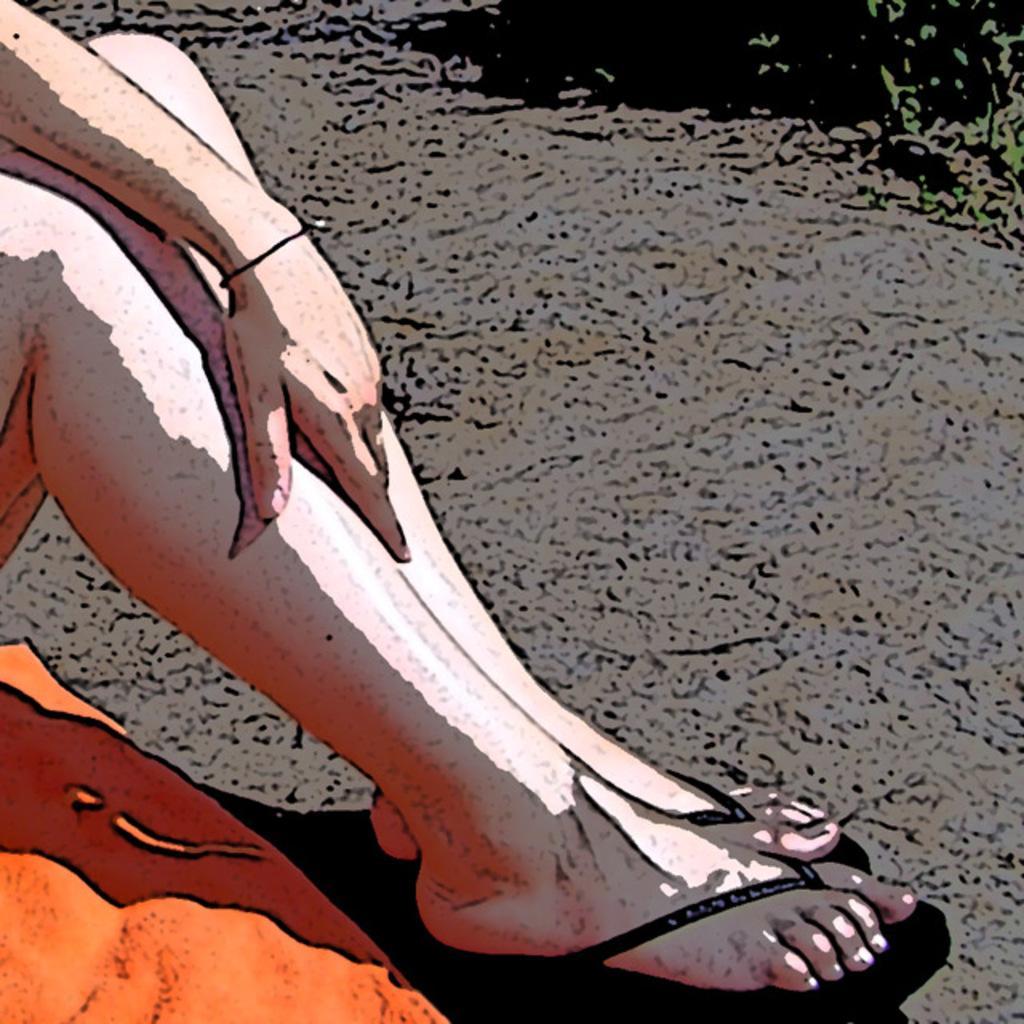Please provide a concise description of this image. In this picture, there is a cartoon. Towards the left, there are human legs and a hat. 